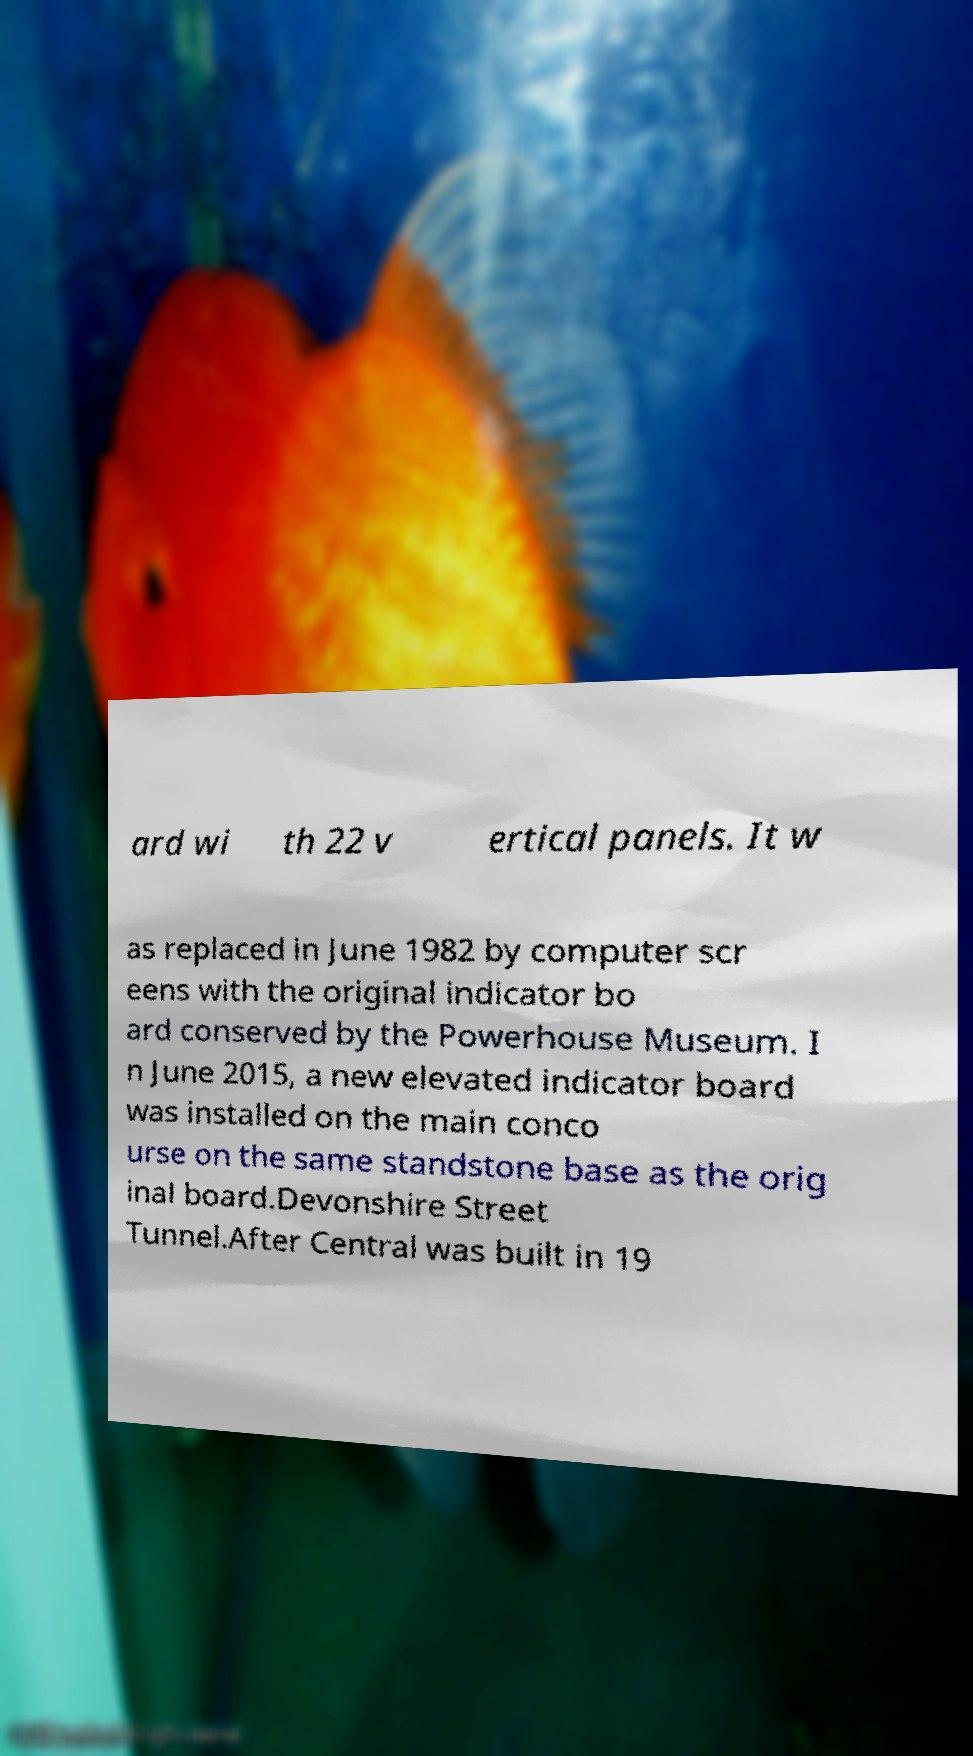Can you accurately transcribe the text from the provided image for me? ard wi th 22 v ertical panels. It w as replaced in June 1982 by computer scr eens with the original indicator bo ard conserved by the Powerhouse Museum. I n June 2015, a new elevated indicator board was installed on the main conco urse on the same standstone base as the orig inal board.Devonshire Street Tunnel.After Central was built in 19 